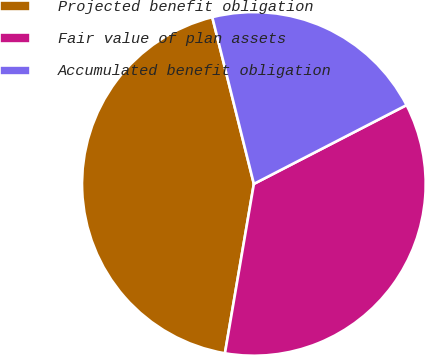<chart> <loc_0><loc_0><loc_500><loc_500><pie_chart><fcel>Projected benefit obligation<fcel>Fair value of plan assets<fcel>Accumulated benefit obligation<nl><fcel>43.42%<fcel>35.28%<fcel>21.31%<nl></chart> 